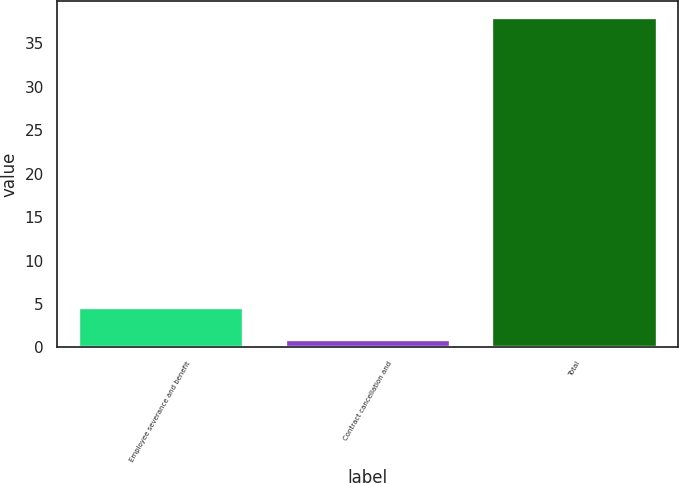Convert chart. <chart><loc_0><loc_0><loc_500><loc_500><bar_chart><fcel>Employee severance and benefit<fcel>Contract cancellation and<fcel>Total<nl><fcel>4.7<fcel>1<fcel>38<nl></chart> 